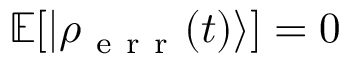Convert formula to latex. <formula><loc_0><loc_0><loc_500><loc_500>\mathbb { E } [ | \rho _ { e r r } ( t ) \rangle ] = 0</formula> 